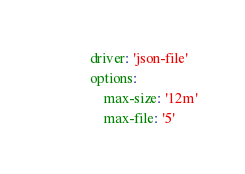Convert code to text. <code><loc_0><loc_0><loc_500><loc_500><_YAML_>            driver: 'json-file'
            options:
                max-size: '12m'
                max-file: '5'

</code> 